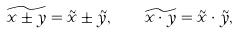<formula> <loc_0><loc_0><loc_500><loc_500>\widetilde { x \pm y } = \tilde { x } \pm \tilde { y } , \quad \widetilde { x \cdot y } = \tilde { x } \cdot \tilde { y } ,</formula> 